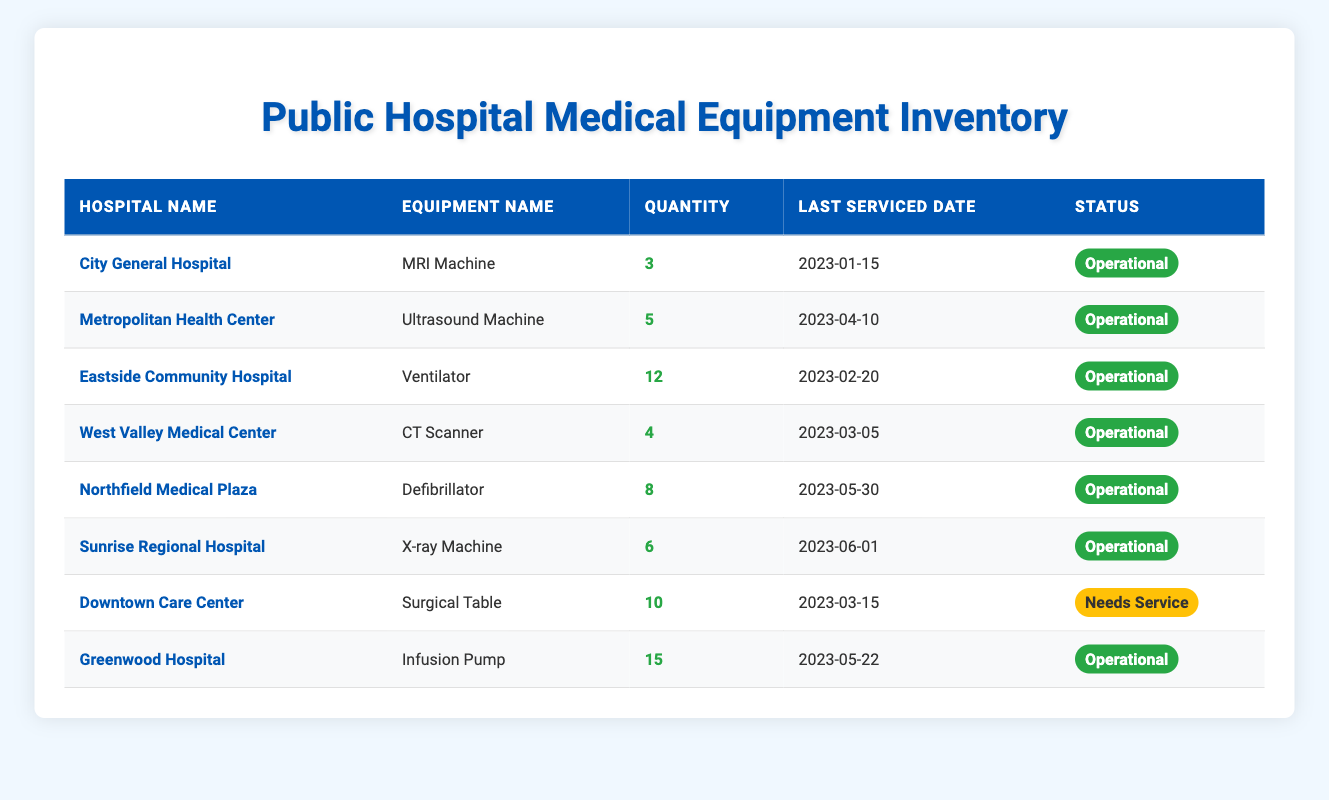What is the quantity of MRI Machines at City General Hospital? According to the table, City General Hospital has 3 MRI Machines listed under the equipment name and quantity columns.
Answer: 3 Which hospital has the highest quantity of Infusion Pumps? The table shows Greenwood Hospital with 15 Infusion Pumps, which is the highest number compared to the other hospitals.
Answer: Greenwood Hospital How many different types of equipment are listed in the table? The table lists a total of 7 different equipment types: MRI Machine, Ultrasound Machine, Ventilator, CT Scanner, Defibrillator, X-ray Machine, Surgical Table, and Infusion Pump, which makes it 7 distinct types.
Answer: 7 What is the total quantity of operational machines across all hospitals? To find the total operational machines, add the quantities of all operational statuses: 3 (MRI) + 5 (Ultrasound) + 12 (Ventilator) + 4 (CT Scanner) + 8 (Defibrillator) + 6 (X-ray) + 15 (Infusion) = 53. Therefore, the total operational machines are 53.
Answer: 53 Is there any equipment in Downtown Care Center that needs service? Yes, the table indicates that the Surgical Table at Downtown Care Center is marked as needing service.
Answer: Yes What is the average quantity of equipment for hospitals that have operational status? First, sum the quantities of operational machines: 3 + 5 + 12 + 4 + 8 + 6 + 15 = 53. There are 7 hospitals in total, so the average is 53 / 7 = 7.57. Thus, the average quantity is approximately 7.57.
Answer: 7.57 How many machines in total are listed for Eastside Community Hospital and West Valley Medical Center? The total machines for Eastside Community Hospital (12 Ventilators) and West Valley Medical Center (4 CT Scanners) is calculated as 12 + 4 = 16. Hence, there are 16 machines in total for these two hospitals.
Answer: 16 Which equipment has the most recent servicing date, and what is that date? By comparing the last serviced dates in the table, the most recent date is June 1, 2023, for the X-ray Machine at Sunrise Regional Hospital.
Answer: June 1, 2023 